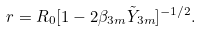<formula> <loc_0><loc_0><loc_500><loc_500>r = R _ { 0 } [ 1 - 2 \beta _ { 3 m } \tilde { Y } _ { 3 m } ] ^ { - 1 / 2 } .</formula> 